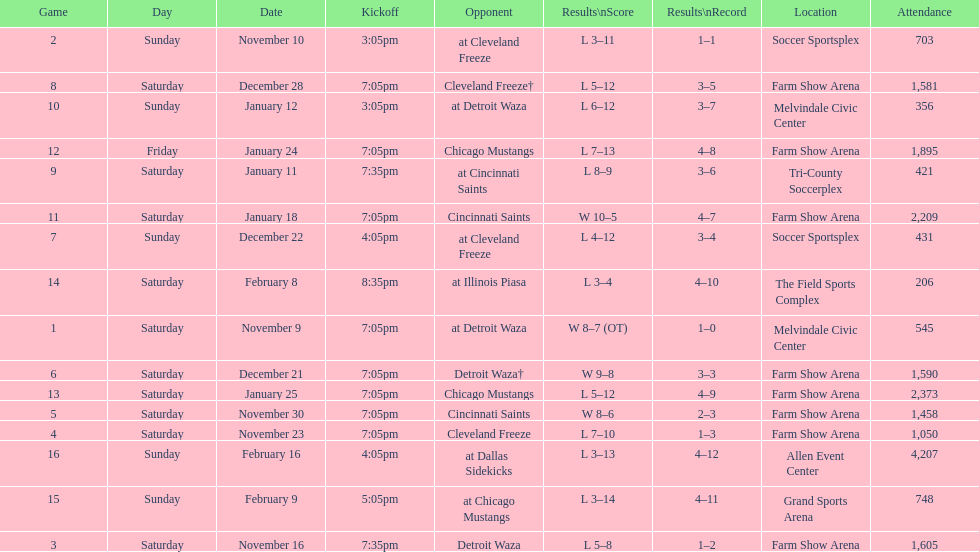What was the location before tri-county soccerplex? Farm Show Arena. 